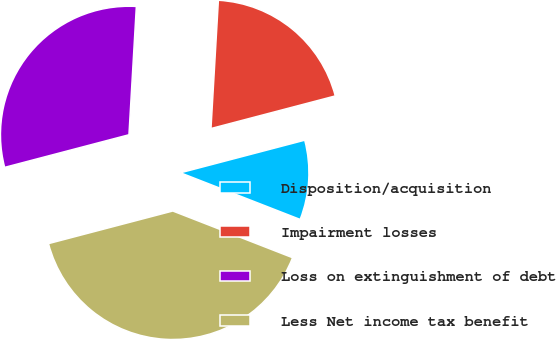Convert chart to OTSL. <chart><loc_0><loc_0><loc_500><loc_500><pie_chart><fcel>Disposition/acquisition<fcel>Impairment losses<fcel>Loss on extinguishment of debt<fcel>Less Net income tax benefit<nl><fcel>10.0%<fcel>20.0%<fcel>30.0%<fcel>40.0%<nl></chart> 